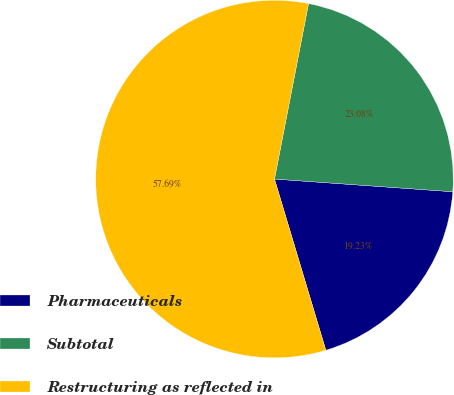<chart> <loc_0><loc_0><loc_500><loc_500><pie_chart><fcel>Pharmaceuticals<fcel>Subtotal<fcel>Restructuring as reflected in<nl><fcel>19.23%<fcel>23.08%<fcel>57.69%<nl></chart> 